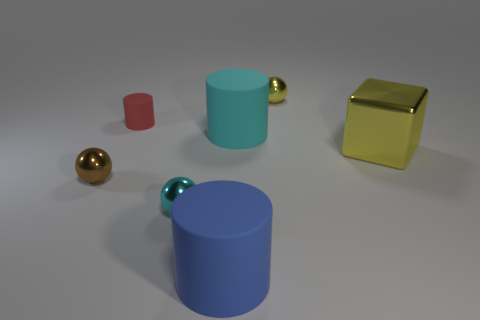Is the color of the cube the same as the small cylinder?
Offer a terse response. No. There is a tiny cylinder that is the same material as the big blue thing; what is its color?
Give a very brief answer. Red. Are there any small balls behind the tiny metallic thing that is behind the cyan cylinder?
Provide a short and direct response. No. What number of other objects are the same shape as the cyan matte object?
Your answer should be very brief. 2. Is the shape of the cyan object that is in front of the block the same as the object that is behind the tiny red matte cylinder?
Offer a terse response. Yes. There is a cyan thing in front of the matte thing that is on the right side of the blue rubber thing; what number of cyan matte cylinders are left of it?
Your response must be concise. 0. The tiny rubber cylinder has what color?
Keep it short and to the point. Red. What number of other objects are the same size as the brown metallic ball?
Give a very brief answer. 3. There is a small brown object that is the same shape as the tiny cyan object; what is its material?
Make the answer very short. Metal. What is the material of the large cylinder in front of the yellow shiny thing to the right of the metallic object that is behind the big yellow thing?
Your response must be concise. Rubber. 